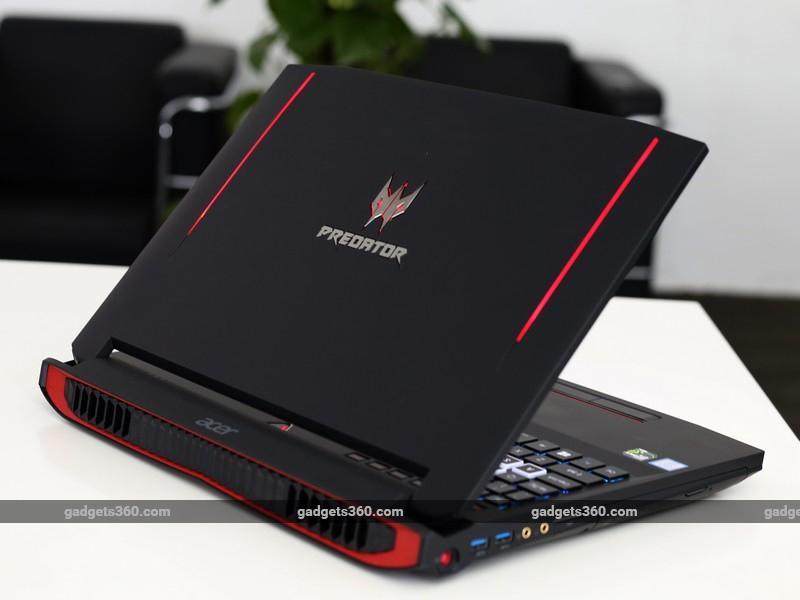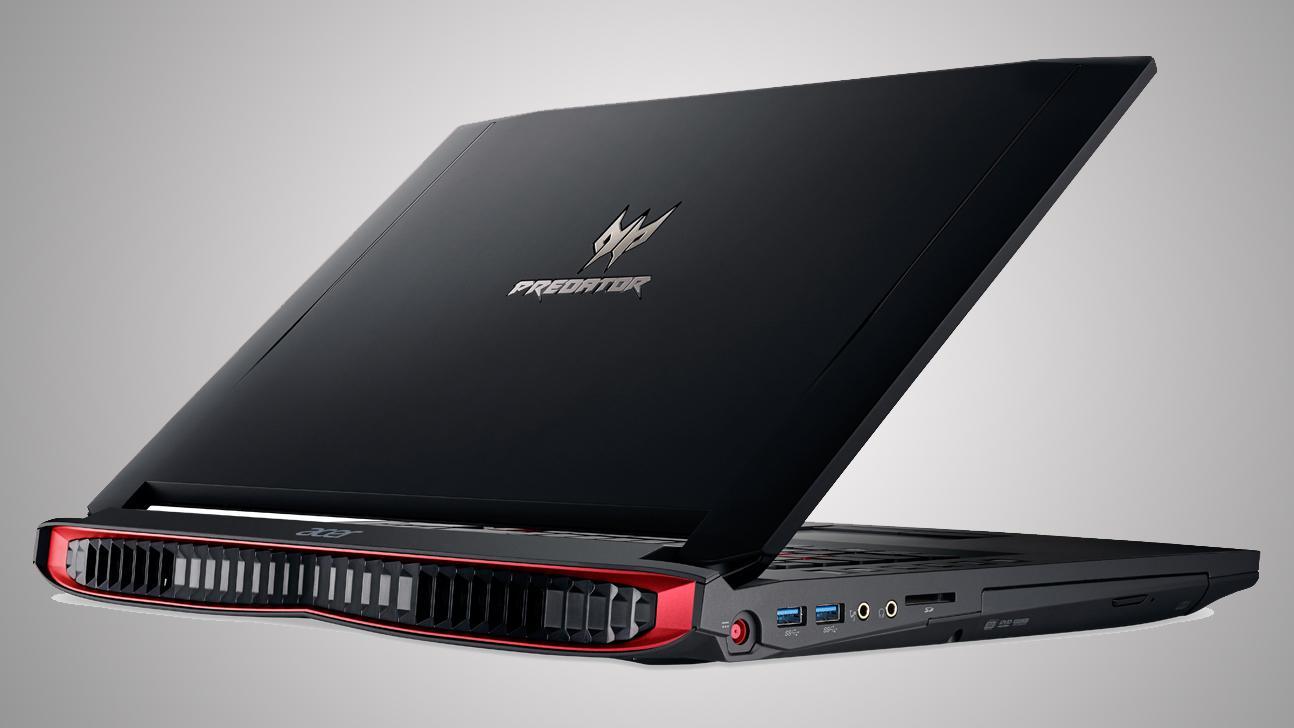The first image is the image on the left, the second image is the image on the right. Considering the images on both sides, is "The laptop on the left is opened to at least 90-degrees and has its screen facing somewhat forward, and the laptop on the right is open to about 45-degrees or less and has its back to the camera." valid? Answer yes or no. No. The first image is the image on the left, the second image is the image on the right. Assess this claim about the two images: "The computer in the image on the right is angled so that the screen isn't visible.". Correct or not? Answer yes or no. Yes. 